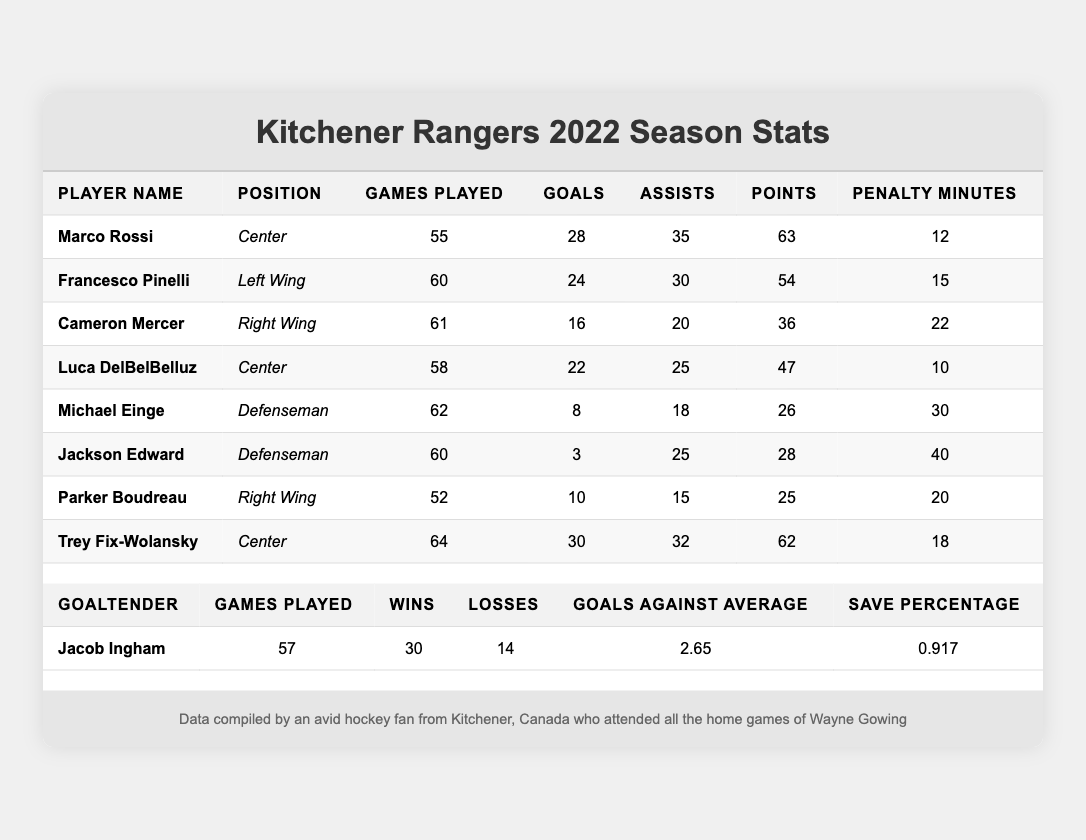What's the total number of goals scored by Marco Rossi? Marco Rossi's goals are listed as 28 in the table.
Answer: 28 What is the position of Francesco Pinelli? The table shows Francesco Pinelli is listed in the position of Left Wing.
Answer: Left Wing How many penalty minutes did Jackson Edward accumulate? Jackson Edward's penalty minutes are recorded as 40 in the table.
Answer: 40 Who scored the highest number of points in the season? By comparing the points column, both Marco Rossi and Trey Fix-Wolansky have 63 and 62 points respectively, thus Marco Rossi scored the highest.
Answer: Marco Rossi What is the average number of games played by the players listed? The games played are: 55, 60, 61, 58, 62, 60, 52, 64. Adding those gives a total of 438. The average is 438 divided by 8 players = 54.75 (or about 55 rounded).
Answer: 55 Did any player score more than 30 goals? Examining the goals column, Trey Fix-Wolansky scored 30 goals, which means there are no players who scored more than 30 goals.
Answer: No What is the total number of assists by all players combined? Summing the assists: 35 + 30 + 20 + 25 + 18 + 25 + 15 + 32 gives a total of 210 assists.
Answer: 210 Which player has the lowest number of goals? By checking the goals column, Jackson Edward has the lowest number with 3 goals.
Answer: Jackson Edward What percentage of games did Jacob Ingham win? Jacob Ingham has 30 wins out of 57 games played. The percentage is calculated as (30/57) * 100 = 52.63%.
Answer: 52.63% How many total points did the top three point scorers achieve? The top three players are Marco Rossi (63), Trey Fix-Wolansky (62), and Francesco Pinelli (54). Adding these gives 63 + 62 + 54 = 179 points.
Answer: 179 